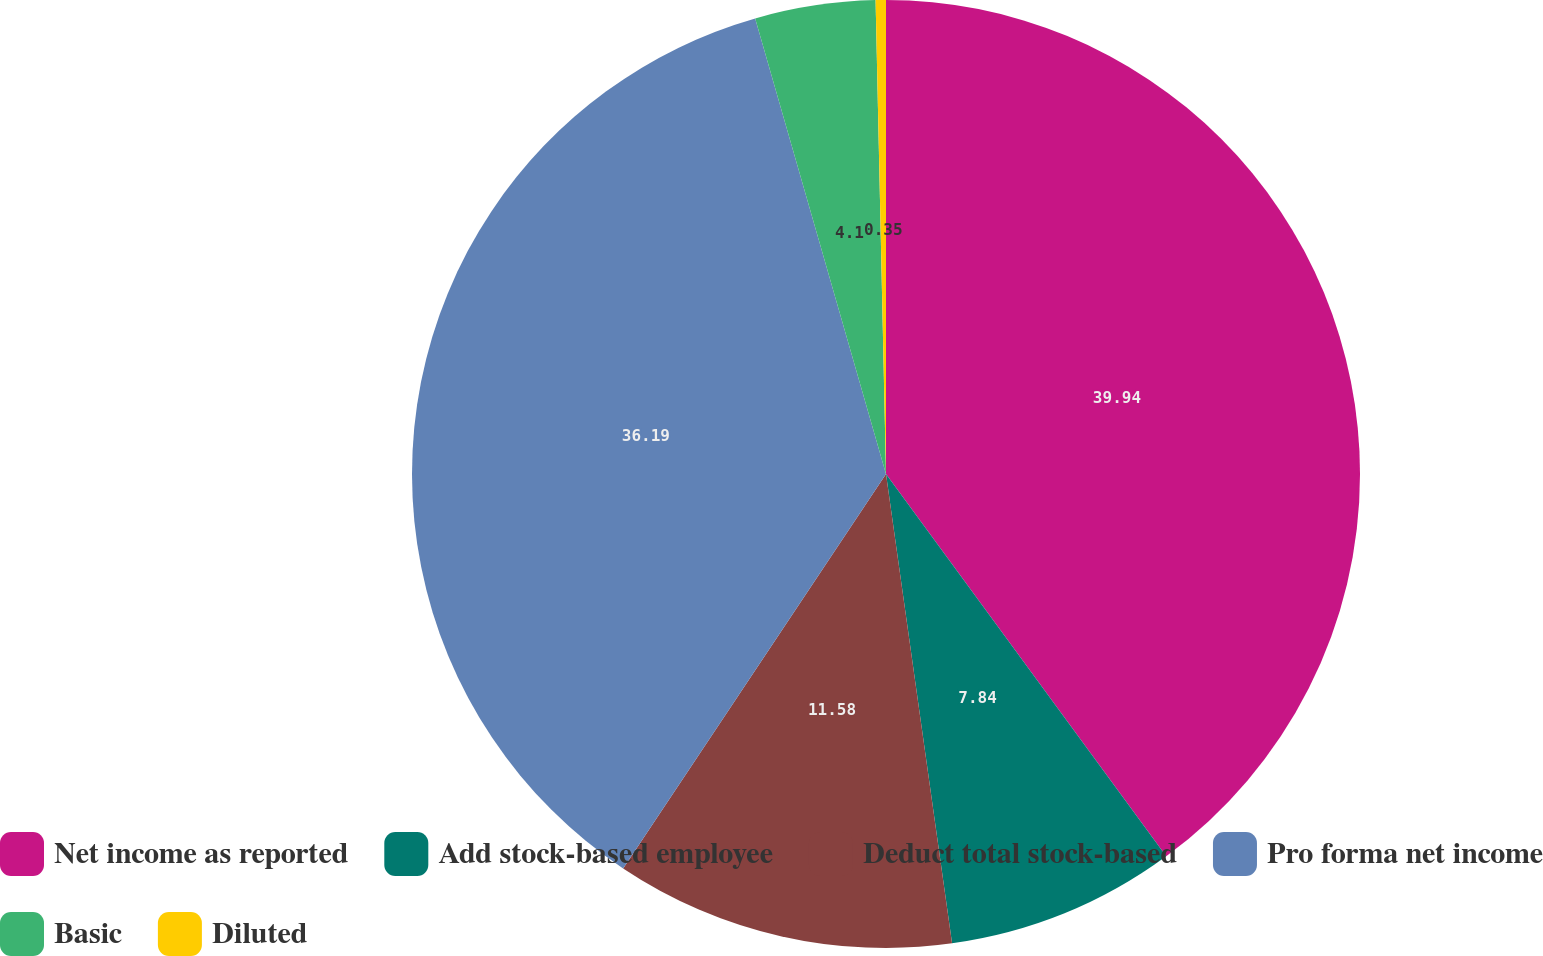Convert chart to OTSL. <chart><loc_0><loc_0><loc_500><loc_500><pie_chart><fcel>Net income as reported<fcel>Add stock-based employee<fcel>Deduct total stock-based<fcel>Pro forma net income<fcel>Basic<fcel>Diluted<nl><fcel>39.93%<fcel>7.84%<fcel>11.58%<fcel>36.19%<fcel>4.1%<fcel>0.35%<nl></chart> 